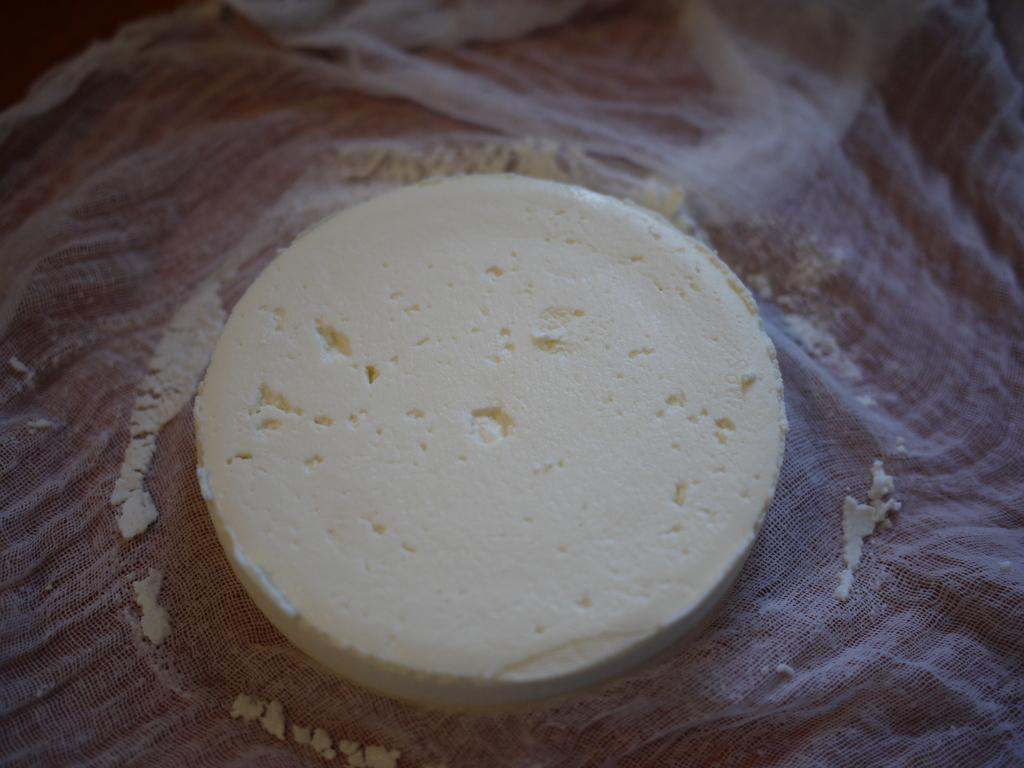What is the main subject of the image? The main subject of the image is a piece of tofu. Can you describe the setting or context in which the tofu is placed? The piece of tofu is on a white cloth. What type of lizards can be seen crawling on the tofu in the image? There are no lizards present in the image; it only features a piece of tofu on a white cloth. 